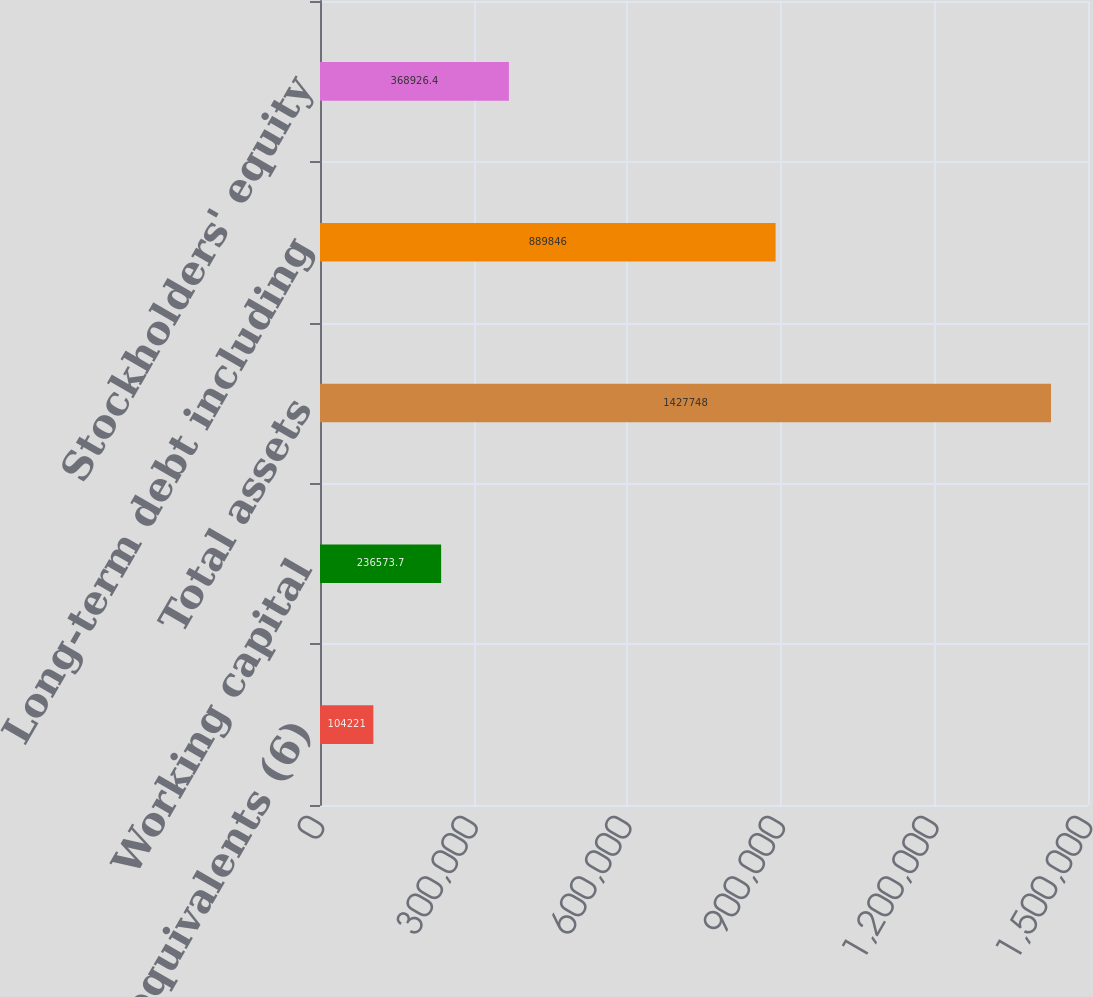Convert chart to OTSL. <chart><loc_0><loc_0><loc_500><loc_500><bar_chart><fcel>Cash and cash equivalents (6)<fcel>Working capital<fcel>Total assets<fcel>Long-term debt including<fcel>Stockholders' equity<nl><fcel>104221<fcel>236574<fcel>1.42775e+06<fcel>889846<fcel>368926<nl></chart> 